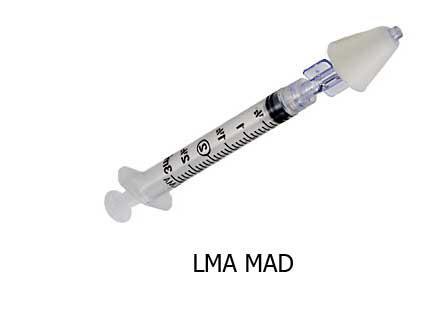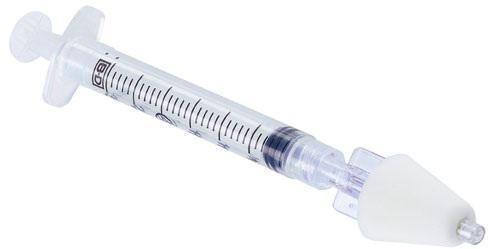The first image is the image on the left, the second image is the image on the right. Given the left and right images, does the statement "There is at least one gloved hand in the picture." hold true? Answer yes or no. No. 